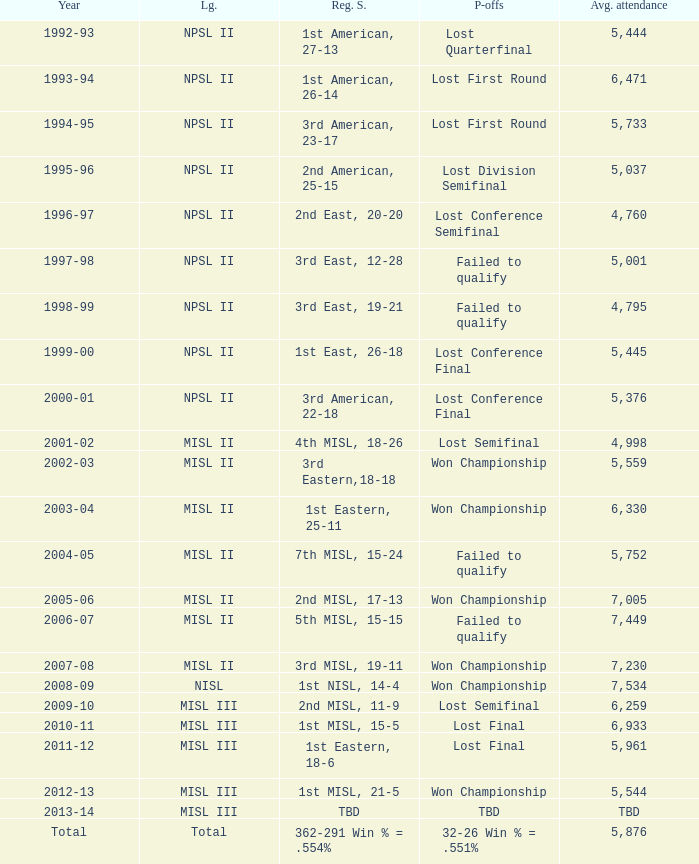When was the year that had an average attendance of 5,445? 1999-00. 